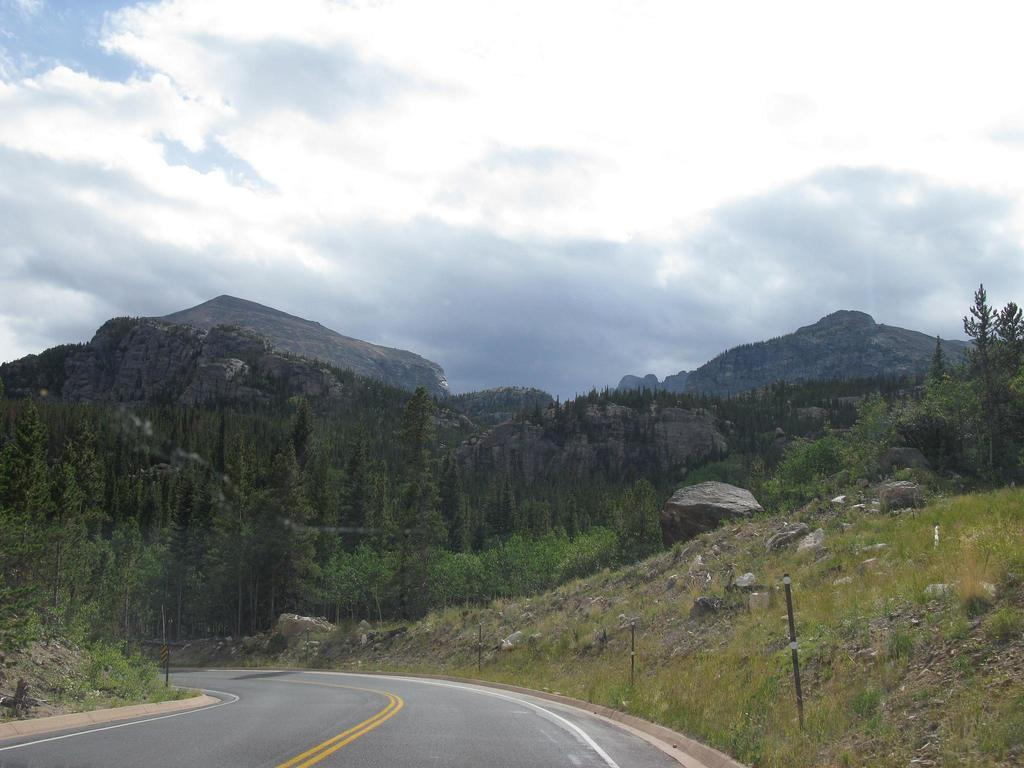What is the main feature of the image? There is a road in the image. What can be seen beside the road? There are stones beside the road. What type of vegetation is present in the image? There is grass in the image. What structures can be seen in the image? There are poles in the image. What is visible in the background of the image? There are mountains, trees, and the sky visible in the background of the image. How many pies are being baked in the oven in the image? There is no oven or pies present in the image. What type of earth can be seen in the image? The image does not show any specific type of earth; it features a road, stones, grass, poles, mountains, trees, and the sky. 